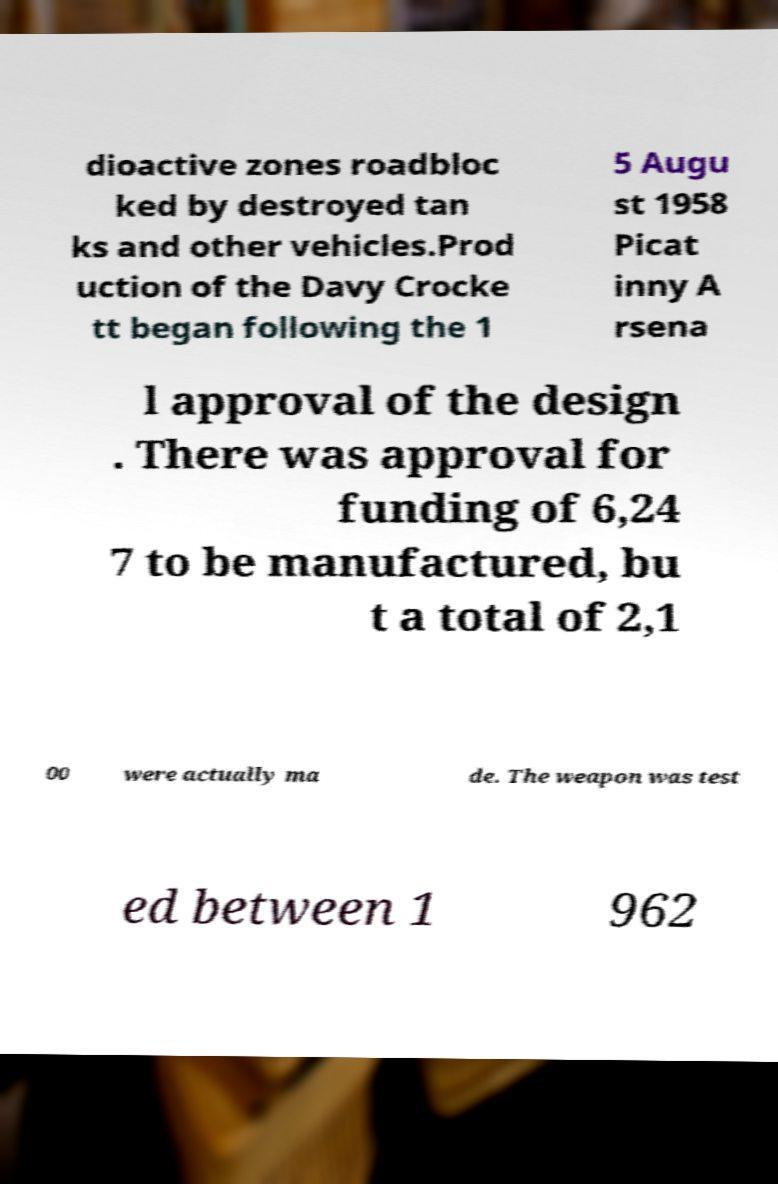Can you accurately transcribe the text from the provided image for me? dioactive zones roadbloc ked by destroyed tan ks and other vehicles.Prod uction of the Davy Crocke tt began following the 1 5 Augu st 1958 Picat inny A rsena l approval of the design . There was approval for funding of 6,24 7 to be manufactured, bu t a total of 2,1 00 were actually ma de. The weapon was test ed between 1 962 